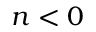Convert formula to latex. <formula><loc_0><loc_0><loc_500><loc_500>n < 0</formula> 